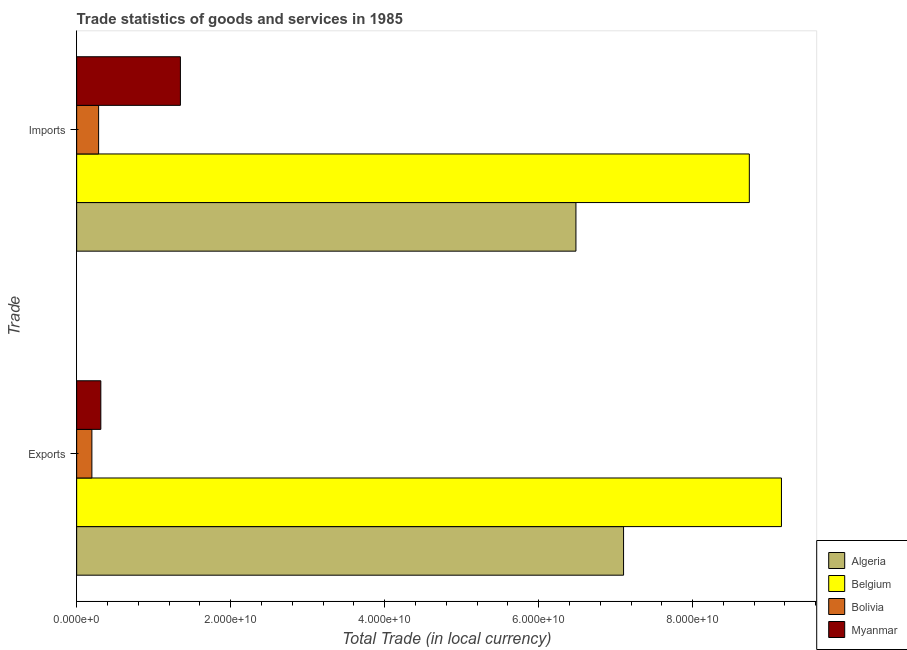Are the number of bars per tick equal to the number of legend labels?
Make the answer very short. Yes. Are the number of bars on each tick of the Y-axis equal?
Ensure brevity in your answer.  Yes. How many bars are there on the 2nd tick from the bottom?
Keep it short and to the point. 4. What is the label of the 1st group of bars from the top?
Your answer should be very brief. Imports. What is the export of goods and services in Belgium?
Your answer should be very brief. 9.15e+1. Across all countries, what is the maximum imports of goods and services?
Your answer should be compact. 8.74e+1. Across all countries, what is the minimum export of goods and services?
Give a very brief answer. 1.98e+09. In which country was the imports of goods and services maximum?
Your response must be concise. Belgium. What is the total imports of goods and services in the graph?
Your answer should be very brief. 1.69e+11. What is the difference between the export of goods and services in Myanmar and that in Belgium?
Give a very brief answer. -8.84e+1. What is the difference between the imports of goods and services in Algeria and the export of goods and services in Belgium?
Your answer should be very brief. -2.67e+1. What is the average imports of goods and services per country?
Offer a terse response. 4.21e+1. What is the difference between the export of goods and services and imports of goods and services in Algeria?
Offer a very short reply. 6.18e+09. What is the ratio of the export of goods and services in Bolivia to that in Myanmar?
Make the answer very short. 0.63. In how many countries, is the export of goods and services greater than the average export of goods and services taken over all countries?
Ensure brevity in your answer.  2. What does the 1st bar from the top in Exports represents?
Your answer should be compact. Myanmar. Does the graph contain grids?
Offer a very short reply. No. How many legend labels are there?
Offer a very short reply. 4. What is the title of the graph?
Make the answer very short. Trade statistics of goods and services in 1985. What is the label or title of the X-axis?
Your answer should be compact. Total Trade (in local currency). What is the label or title of the Y-axis?
Make the answer very short. Trade. What is the Total Trade (in local currency) of Algeria in Exports?
Provide a short and direct response. 7.10e+1. What is the Total Trade (in local currency) in Belgium in Exports?
Your answer should be very brief. 9.15e+1. What is the Total Trade (in local currency) of Bolivia in Exports?
Offer a terse response. 1.98e+09. What is the Total Trade (in local currency) in Myanmar in Exports?
Offer a very short reply. 3.14e+09. What is the Total Trade (in local currency) in Algeria in Imports?
Give a very brief answer. 6.48e+1. What is the Total Trade (in local currency) in Belgium in Imports?
Keep it short and to the point. 8.74e+1. What is the Total Trade (in local currency) of Bolivia in Imports?
Give a very brief answer. 2.85e+09. What is the Total Trade (in local currency) of Myanmar in Imports?
Your response must be concise. 1.35e+1. Across all Trade, what is the maximum Total Trade (in local currency) in Algeria?
Offer a terse response. 7.10e+1. Across all Trade, what is the maximum Total Trade (in local currency) of Belgium?
Ensure brevity in your answer.  9.15e+1. Across all Trade, what is the maximum Total Trade (in local currency) of Bolivia?
Provide a short and direct response. 2.85e+09. Across all Trade, what is the maximum Total Trade (in local currency) in Myanmar?
Your answer should be very brief. 1.35e+1. Across all Trade, what is the minimum Total Trade (in local currency) of Algeria?
Offer a terse response. 6.48e+1. Across all Trade, what is the minimum Total Trade (in local currency) in Belgium?
Ensure brevity in your answer.  8.74e+1. Across all Trade, what is the minimum Total Trade (in local currency) in Bolivia?
Ensure brevity in your answer.  1.98e+09. Across all Trade, what is the minimum Total Trade (in local currency) of Myanmar?
Offer a very short reply. 3.14e+09. What is the total Total Trade (in local currency) of Algeria in the graph?
Your answer should be compact. 1.36e+11. What is the total Total Trade (in local currency) of Belgium in the graph?
Your answer should be compact. 1.79e+11. What is the total Total Trade (in local currency) of Bolivia in the graph?
Offer a terse response. 4.83e+09. What is the total Total Trade (in local currency) of Myanmar in the graph?
Offer a very short reply. 1.66e+1. What is the difference between the Total Trade (in local currency) in Algeria in Exports and that in Imports?
Provide a succinct answer. 6.18e+09. What is the difference between the Total Trade (in local currency) in Belgium in Exports and that in Imports?
Provide a succinct answer. 4.17e+09. What is the difference between the Total Trade (in local currency) in Bolivia in Exports and that in Imports?
Ensure brevity in your answer.  -8.74e+08. What is the difference between the Total Trade (in local currency) of Myanmar in Exports and that in Imports?
Make the answer very short. -1.03e+1. What is the difference between the Total Trade (in local currency) in Algeria in Exports and the Total Trade (in local currency) in Belgium in Imports?
Offer a very short reply. -1.63e+1. What is the difference between the Total Trade (in local currency) in Algeria in Exports and the Total Trade (in local currency) in Bolivia in Imports?
Make the answer very short. 6.82e+1. What is the difference between the Total Trade (in local currency) of Algeria in Exports and the Total Trade (in local currency) of Myanmar in Imports?
Your response must be concise. 5.76e+1. What is the difference between the Total Trade (in local currency) of Belgium in Exports and the Total Trade (in local currency) of Bolivia in Imports?
Make the answer very short. 8.87e+1. What is the difference between the Total Trade (in local currency) in Belgium in Exports and the Total Trade (in local currency) in Myanmar in Imports?
Your response must be concise. 7.81e+1. What is the difference between the Total Trade (in local currency) in Bolivia in Exports and the Total Trade (in local currency) in Myanmar in Imports?
Give a very brief answer. -1.15e+1. What is the average Total Trade (in local currency) in Algeria per Trade?
Your answer should be very brief. 6.79e+1. What is the average Total Trade (in local currency) of Belgium per Trade?
Make the answer very short. 8.95e+1. What is the average Total Trade (in local currency) of Bolivia per Trade?
Keep it short and to the point. 2.41e+09. What is the average Total Trade (in local currency) in Myanmar per Trade?
Your answer should be compact. 8.31e+09. What is the difference between the Total Trade (in local currency) of Algeria and Total Trade (in local currency) of Belgium in Exports?
Your response must be concise. -2.05e+1. What is the difference between the Total Trade (in local currency) in Algeria and Total Trade (in local currency) in Bolivia in Exports?
Ensure brevity in your answer.  6.91e+1. What is the difference between the Total Trade (in local currency) in Algeria and Total Trade (in local currency) in Myanmar in Exports?
Provide a short and direct response. 6.79e+1. What is the difference between the Total Trade (in local currency) in Belgium and Total Trade (in local currency) in Bolivia in Exports?
Offer a terse response. 8.96e+1. What is the difference between the Total Trade (in local currency) in Belgium and Total Trade (in local currency) in Myanmar in Exports?
Provide a succinct answer. 8.84e+1. What is the difference between the Total Trade (in local currency) of Bolivia and Total Trade (in local currency) of Myanmar in Exports?
Your answer should be very brief. -1.16e+09. What is the difference between the Total Trade (in local currency) of Algeria and Total Trade (in local currency) of Belgium in Imports?
Give a very brief answer. -2.25e+1. What is the difference between the Total Trade (in local currency) of Algeria and Total Trade (in local currency) of Bolivia in Imports?
Offer a terse response. 6.20e+1. What is the difference between the Total Trade (in local currency) in Algeria and Total Trade (in local currency) in Myanmar in Imports?
Make the answer very short. 5.14e+1. What is the difference between the Total Trade (in local currency) of Belgium and Total Trade (in local currency) of Bolivia in Imports?
Your answer should be compact. 8.45e+1. What is the difference between the Total Trade (in local currency) of Belgium and Total Trade (in local currency) of Myanmar in Imports?
Offer a very short reply. 7.39e+1. What is the difference between the Total Trade (in local currency) of Bolivia and Total Trade (in local currency) of Myanmar in Imports?
Your answer should be very brief. -1.06e+1. What is the ratio of the Total Trade (in local currency) of Algeria in Exports to that in Imports?
Your response must be concise. 1.1. What is the ratio of the Total Trade (in local currency) of Belgium in Exports to that in Imports?
Ensure brevity in your answer.  1.05. What is the ratio of the Total Trade (in local currency) of Bolivia in Exports to that in Imports?
Provide a short and direct response. 0.69. What is the ratio of the Total Trade (in local currency) of Myanmar in Exports to that in Imports?
Keep it short and to the point. 0.23. What is the difference between the highest and the second highest Total Trade (in local currency) of Algeria?
Offer a terse response. 6.18e+09. What is the difference between the highest and the second highest Total Trade (in local currency) in Belgium?
Give a very brief answer. 4.17e+09. What is the difference between the highest and the second highest Total Trade (in local currency) of Bolivia?
Ensure brevity in your answer.  8.74e+08. What is the difference between the highest and the second highest Total Trade (in local currency) of Myanmar?
Provide a short and direct response. 1.03e+1. What is the difference between the highest and the lowest Total Trade (in local currency) in Algeria?
Offer a terse response. 6.18e+09. What is the difference between the highest and the lowest Total Trade (in local currency) of Belgium?
Make the answer very short. 4.17e+09. What is the difference between the highest and the lowest Total Trade (in local currency) of Bolivia?
Give a very brief answer. 8.74e+08. What is the difference between the highest and the lowest Total Trade (in local currency) in Myanmar?
Provide a succinct answer. 1.03e+1. 